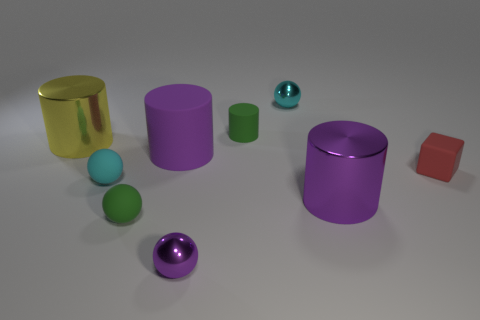There is a big matte cylinder; are there any purple objects to the right of it?
Provide a succinct answer. Yes. What number of big things are purple metal balls or blue metal spheres?
Offer a terse response. 0. Are the tiny green cylinder and the green ball made of the same material?
Make the answer very short. Yes. The ball that is the same color as the large rubber cylinder is what size?
Make the answer very short. Small. Are there any tiny rubber objects that have the same color as the small cylinder?
Offer a terse response. Yes. What is the size of the cyan object that is the same material as the large yellow cylinder?
Make the answer very short. Small. What shape is the small cyan thing in front of the metal ball that is behind the large purple cylinder in front of the cube?
Make the answer very short. Sphere. The other purple object that is the same shape as the big matte thing is what size?
Your answer should be compact. Large. What is the size of the metallic thing that is behind the small block and on the right side of the small purple thing?
Provide a succinct answer. Small. What is the shape of the small metal thing that is the same color as the large rubber cylinder?
Your answer should be compact. Sphere. 